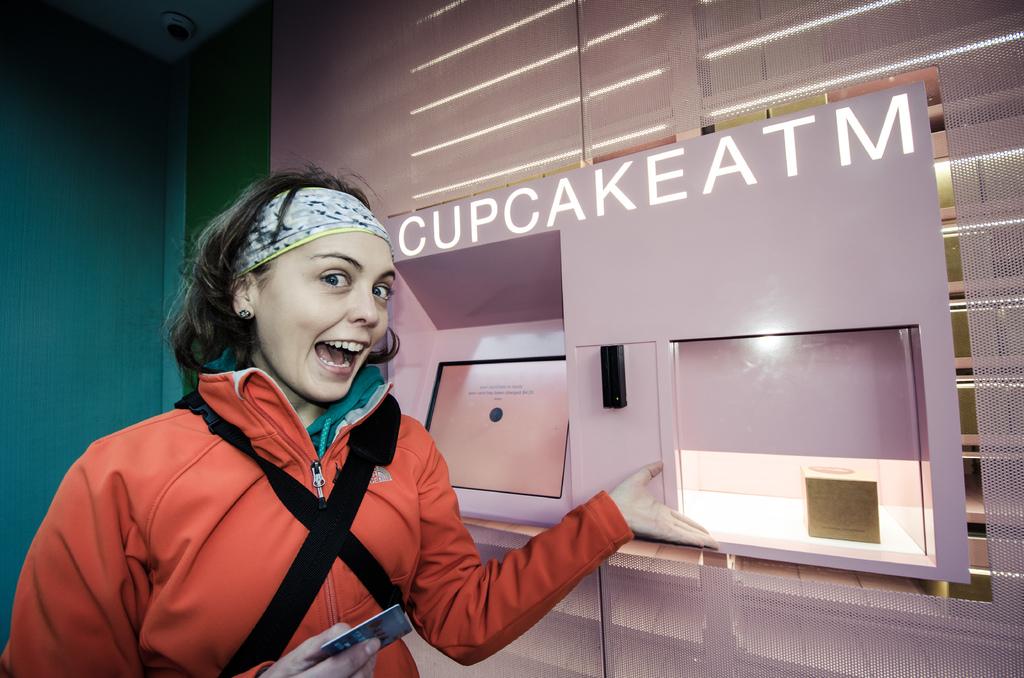What does the atm dispense?
Make the answer very short. Cupcake. What kind of machine is this?
Your answer should be compact. Cupcake atm. 